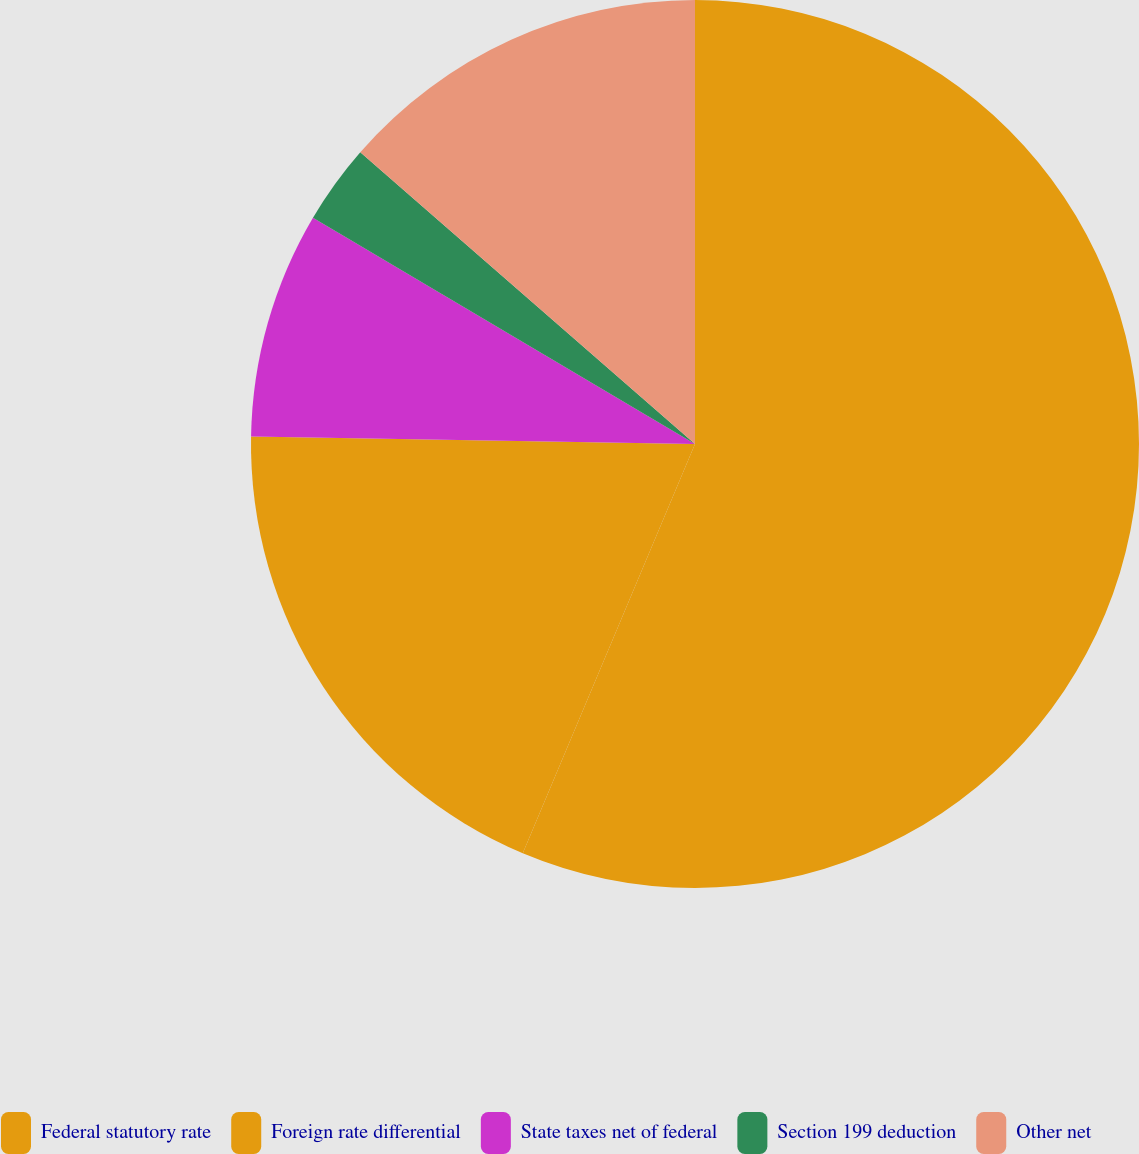Convert chart. <chart><loc_0><loc_0><loc_500><loc_500><pie_chart><fcel>Federal statutory rate<fcel>Foreign rate differential<fcel>State taxes net of federal<fcel>Section 199 deduction<fcel>Other net<nl><fcel>56.34%<fcel>18.93%<fcel>8.24%<fcel>2.9%<fcel>13.59%<nl></chart> 